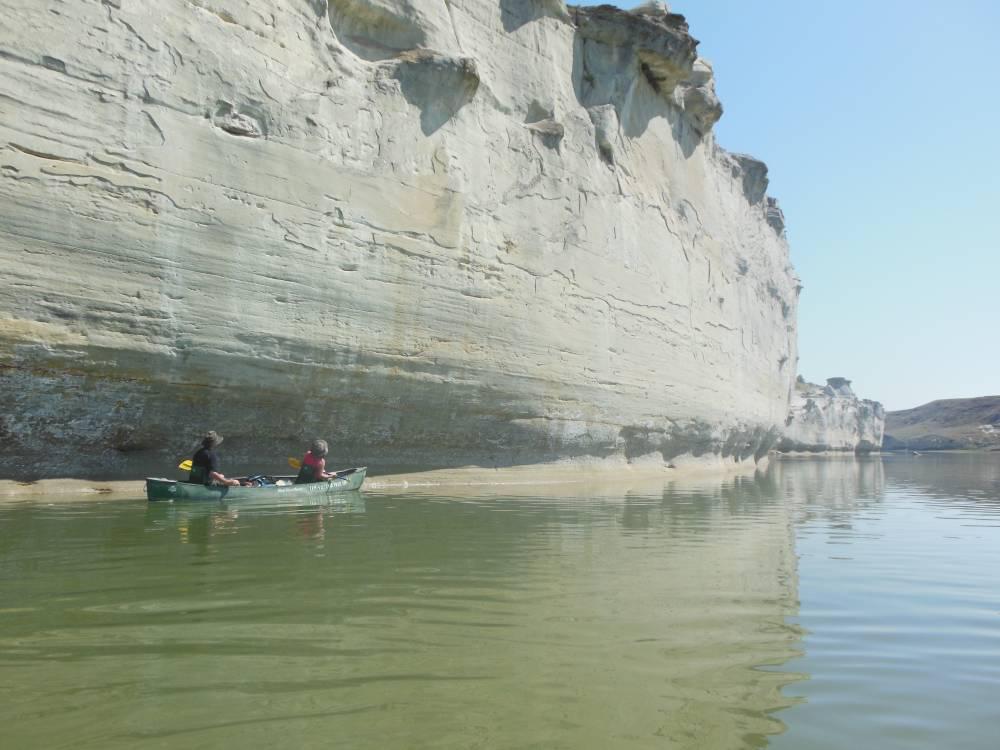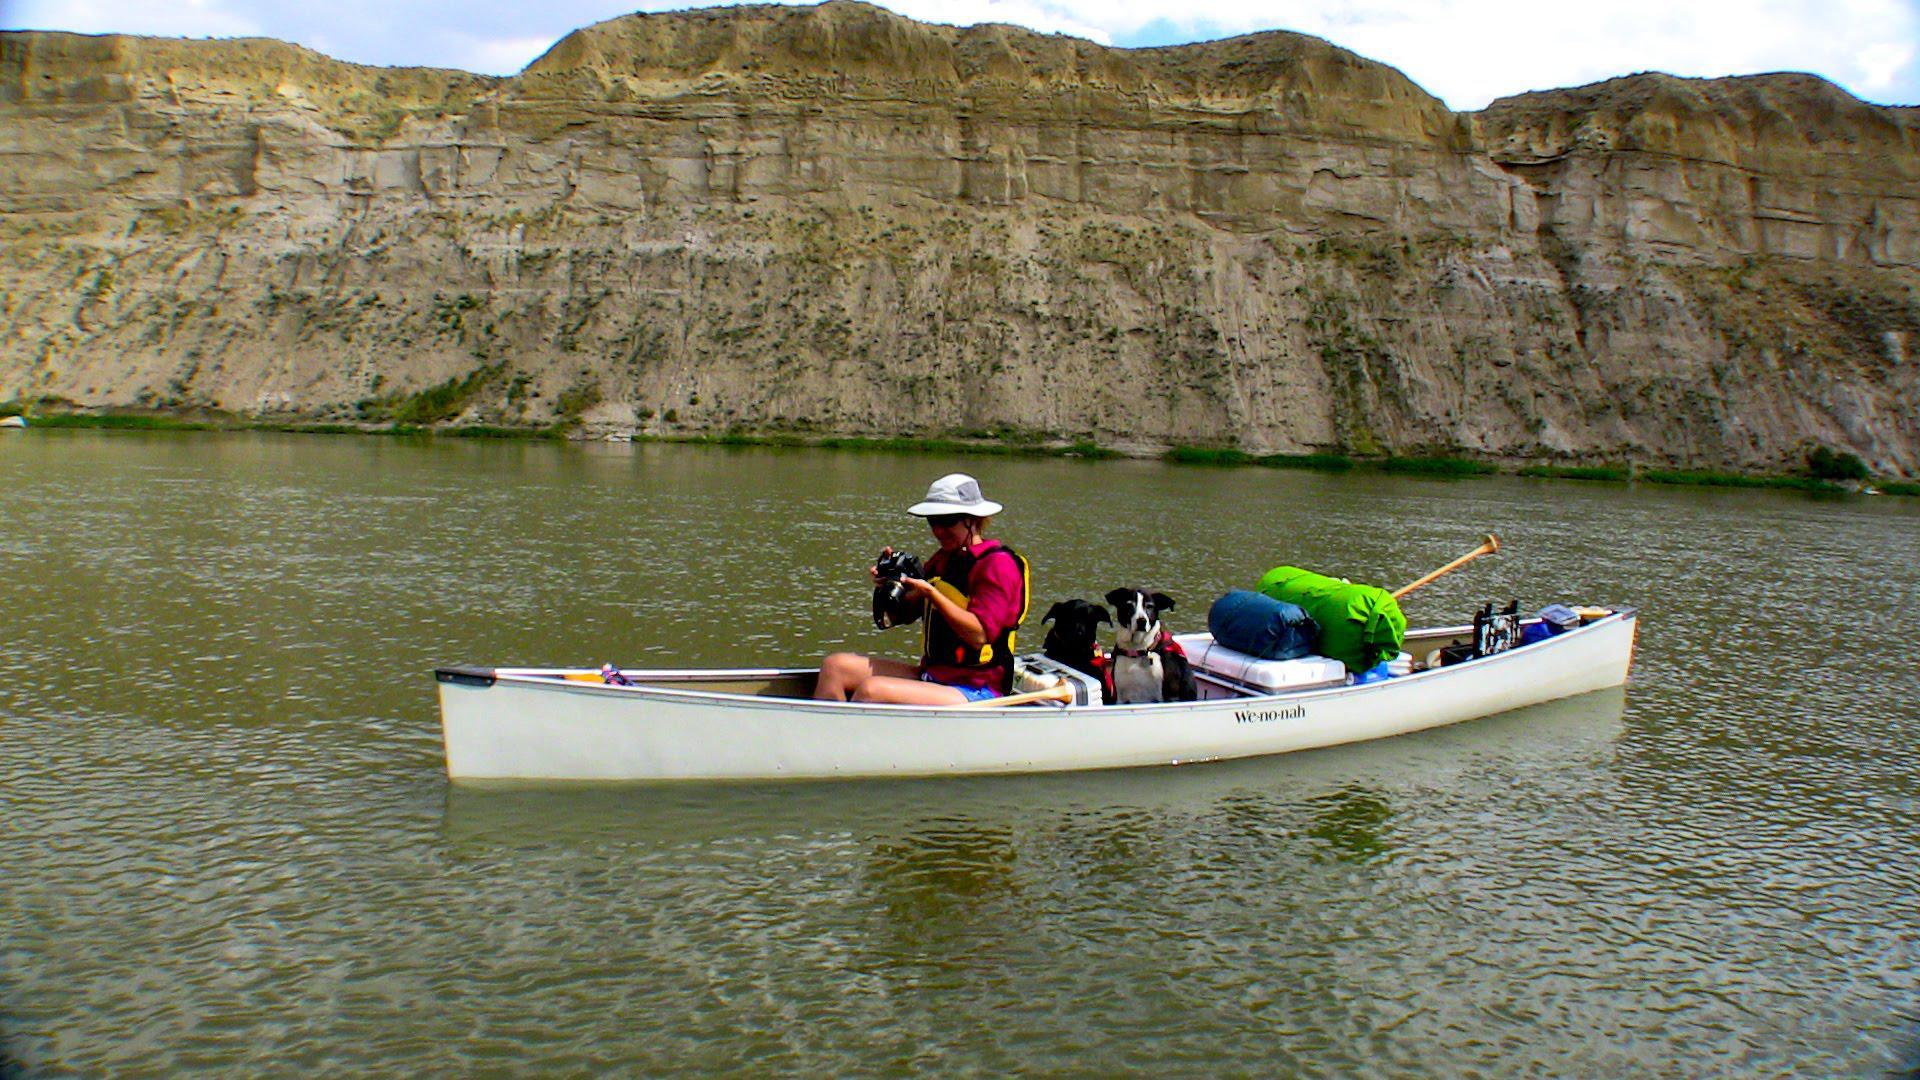The first image is the image on the left, the second image is the image on the right. Evaluate the accuracy of this statement regarding the images: "There are two people riding a single canoe in the lefthand image.". Is it true? Answer yes or no. Yes. The first image is the image on the left, the second image is the image on the right. For the images shown, is this caption "at least one boat has an oar touching the water surface in the image pair" true? Answer yes or no. No. 